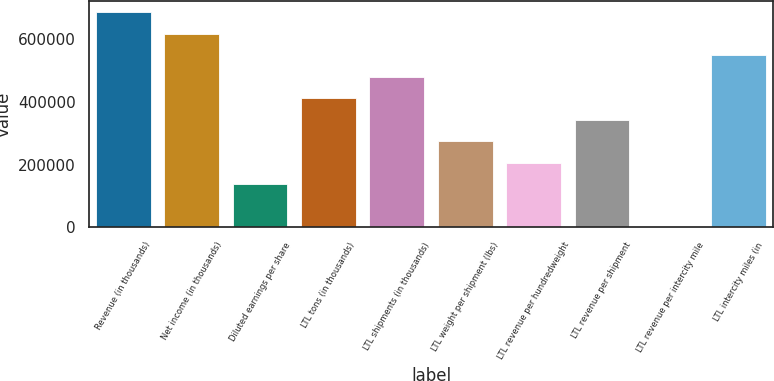Convert chart to OTSL. <chart><loc_0><loc_0><loc_500><loc_500><bar_chart><fcel>Revenue (in thousands)<fcel>Net income (in thousands)<fcel>Diluted earnings per share<fcel>LTL tons (in thousands)<fcel>LTL shipments (in thousands)<fcel>LTL weight per shipment (lbs)<fcel>LTL revenue per hundredweight<fcel>LTL revenue per shipment<fcel>LTL revenue per intercity mile<fcel>LTL intercity miles (in<nl><fcel>685583<fcel>617025<fcel>137117<fcel>411350<fcel>479908<fcel>274233<fcel>205675<fcel>342792<fcel>0.45<fcel>548466<nl></chart> 